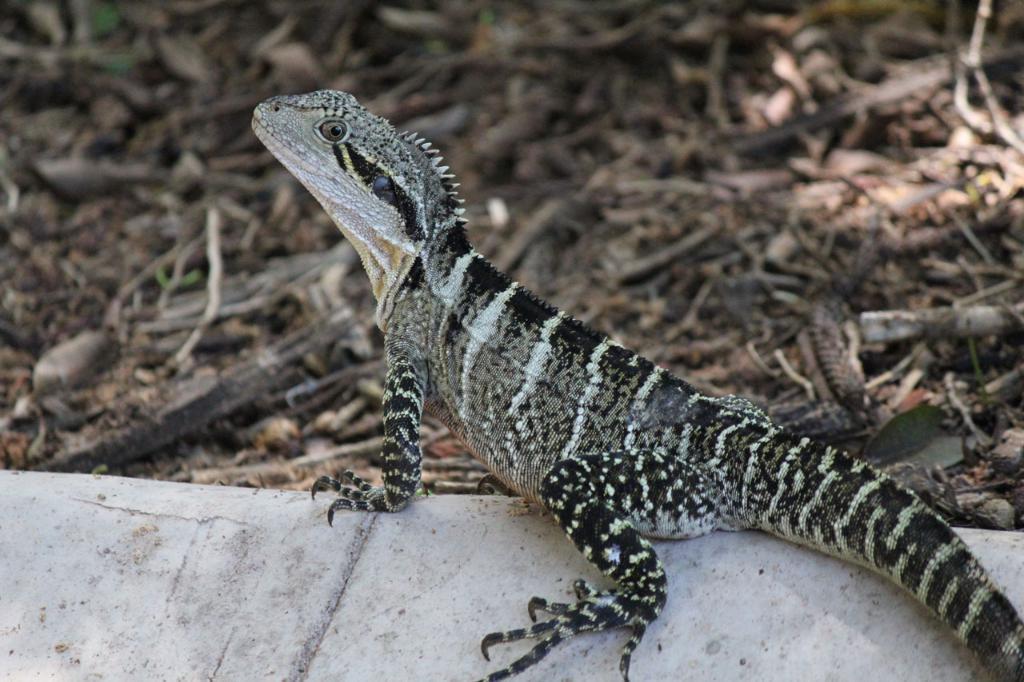How would you summarize this image in a sentence or two? In this image in the center there is one lizard on the wall, and in the background there are some stones and scrap. 